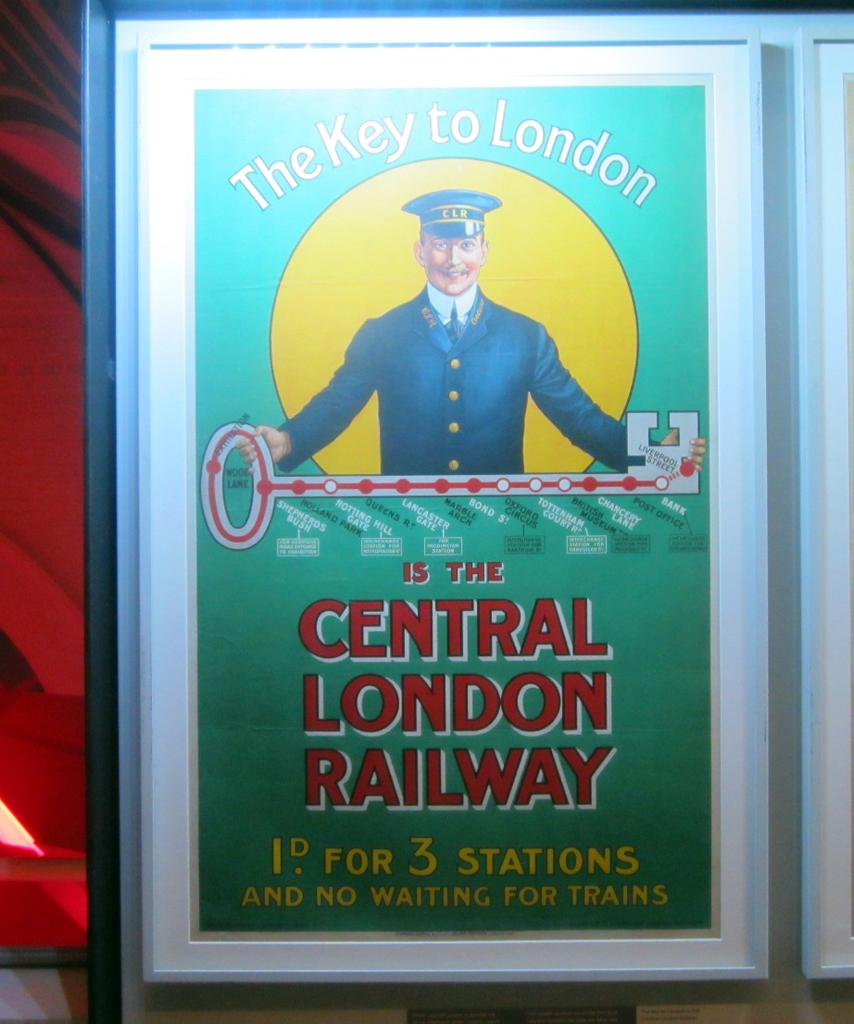<image>
Render a clear and concise summary of the photo. A green sign shows a man with the text of "The Key to London." 